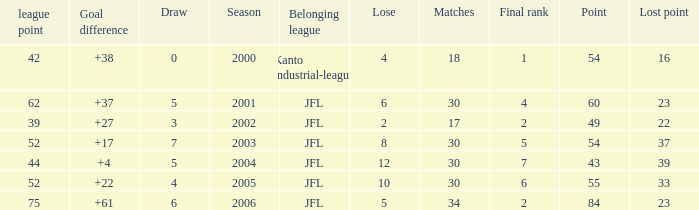Tell me the highest matches for point 43 and final rank less than 7 None. 